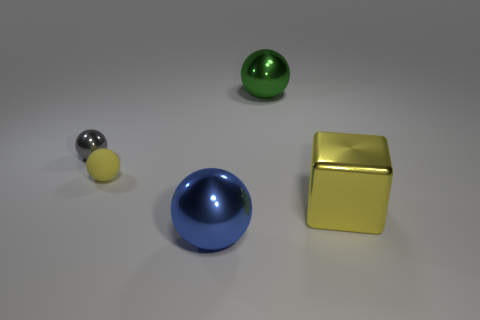Is there symmetry or pattern to the arrangement of the objects? There isn't a clear symmetry or pattern in the arrangement of the objects. Each object is distinct in shape and size, placed at seemingly arbitrary distances from one another, without a discernible pattern or order. Could you imagine a way to rearrange them to create symmetry? To create symmetry, you could place the yellow cube in the center with the silver and black sphere and the blue hemisphere on either side at equal distances. The smaller yellow sphere could then be equally spaced in line with the other two spherical objects. 